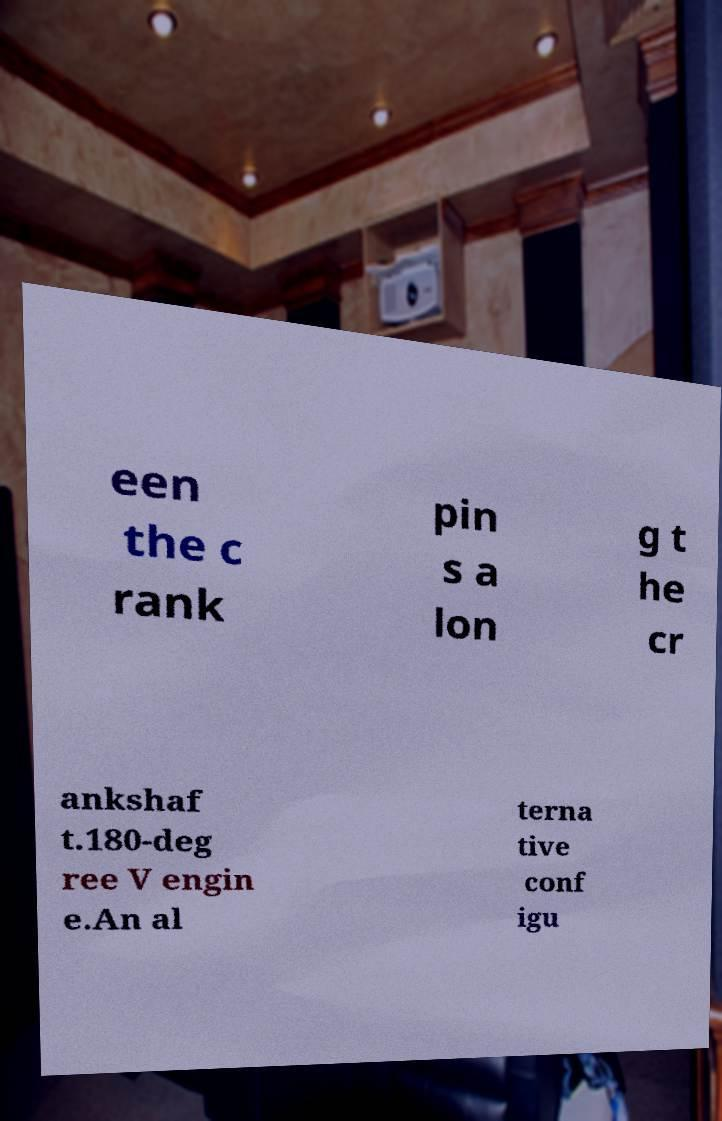Please identify and transcribe the text found in this image. een the c rank pin s a lon g t he cr ankshaf t.180-deg ree V engin e.An al terna tive conf igu 